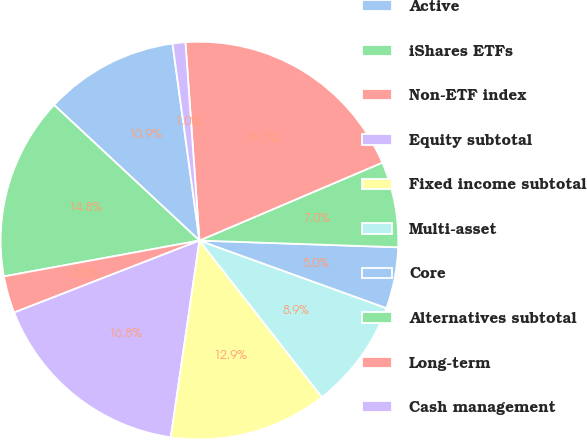<chart> <loc_0><loc_0><loc_500><loc_500><pie_chart><fcel>Active<fcel>iShares ETFs<fcel>Non-ETF index<fcel>Equity subtotal<fcel>Fixed income subtotal<fcel>Multi-asset<fcel>Core<fcel>Alternatives subtotal<fcel>Long-term<fcel>Cash management<nl><fcel>10.89%<fcel>14.83%<fcel>3.01%<fcel>16.8%<fcel>12.86%<fcel>8.92%<fcel>4.98%<fcel>6.95%<fcel>19.71%<fcel>1.04%<nl></chart> 